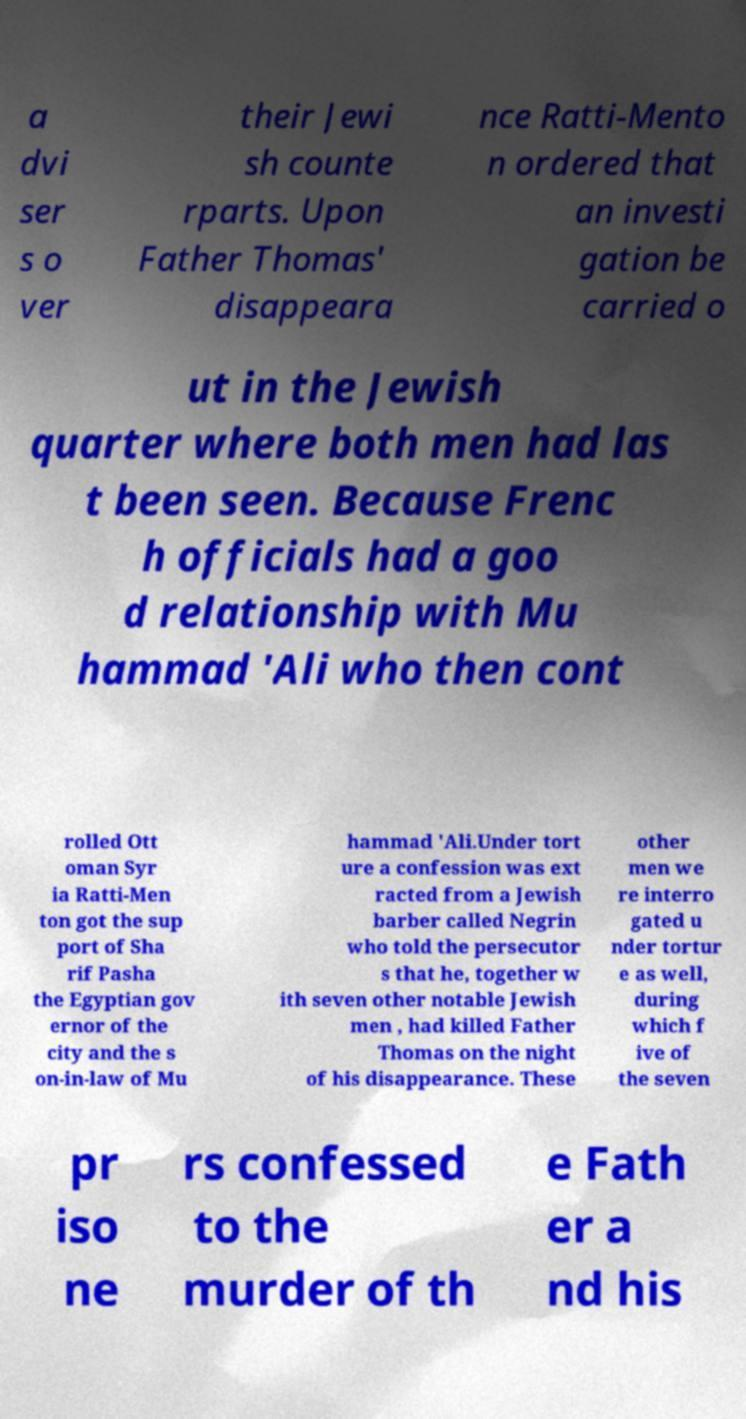Can you accurately transcribe the text from the provided image for me? a dvi ser s o ver their Jewi sh counte rparts. Upon Father Thomas' disappeara nce Ratti-Mento n ordered that an investi gation be carried o ut in the Jewish quarter where both men had las t been seen. Because Frenc h officials had a goo d relationship with Mu hammad 'Ali who then cont rolled Ott oman Syr ia Ratti-Men ton got the sup port of Sha rif Pasha the Egyptian gov ernor of the city and the s on-in-law of Mu hammad 'Ali.Under tort ure a confession was ext racted from a Jewish barber called Negrin who told the persecutor s that he, together w ith seven other notable Jewish men , had killed Father Thomas on the night of his disappearance. These other men we re interro gated u nder tortur e as well, during which f ive of the seven pr iso ne rs confessed to the murder of th e Fath er a nd his 